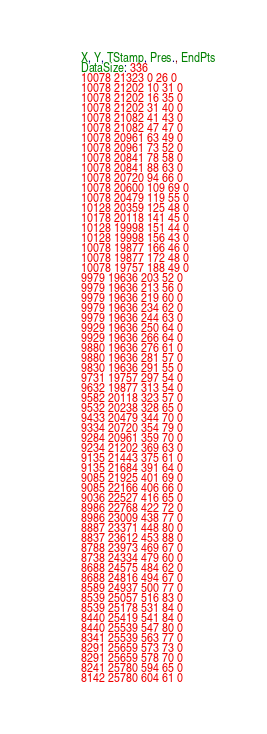<code> <loc_0><loc_0><loc_500><loc_500><_SML_>X, Y, TStamp, Pres., EndPts
DataSize: 336
10078 21323 0 26 0
10078 21202 10 31 0
10078 21202 16 35 0
10078 21202 31 40 0
10078 21082 41 43 0
10078 21082 47 47 0
10078 20961 63 49 0
10078 20961 73 52 0
10078 20841 78 58 0
10078 20841 88 63 0
10078 20720 94 66 0
10078 20600 109 69 0
10078 20479 119 55 0
10128 20359 125 48 0
10178 20118 141 45 0
10128 19998 151 44 0
10128 19998 156 43 0
10078 19877 166 46 0
10078 19877 172 48 0
10078 19757 188 49 0
9979 19636 203 52 0
9979 19636 213 56 0
9979 19636 219 60 0
9979 19636 234 62 0
9979 19636 244 63 0
9929 19636 250 64 0
9929 19636 266 64 0
9880 19636 276 61 0
9880 19636 281 57 0
9830 19636 291 55 0
9731 19757 297 54 0
9632 19877 313 54 0
9582 20118 323 57 0
9532 20238 328 65 0
9433 20479 344 70 0
9334 20720 354 79 0
9284 20961 359 70 0
9234 21202 369 63 0
9135 21443 375 61 0
9135 21684 391 64 0
9085 21925 401 69 0
9085 22166 406 66 0
9036 22527 416 65 0
8986 22768 422 72 0
8986 23009 438 77 0
8887 23371 448 80 0
8837 23612 453 88 0
8788 23973 469 67 0
8738 24334 479 60 0
8688 24575 484 62 0
8688 24816 494 67 0
8589 24937 500 77 0
8539 25057 516 83 0
8539 25178 531 84 0
8440 25419 541 84 0
8440 25539 547 80 0
8341 25539 563 77 0
8291 25659 573 73 0
8291 25659 578 70 0
8241 25780 594 65 0
8142 25780 604 61 0</code> 